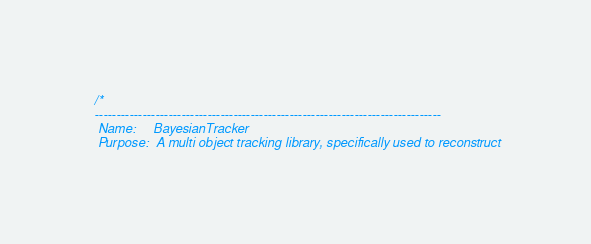Convert code to text. <code><loc_0><loc_0><loc_500><loc_500><_Cuda_>/*
--------------------------------------------------------------------------------
 Name:     BayesianTracker
 Purpose:  A multi object tracking library, specifically used to reconstruct</code> 